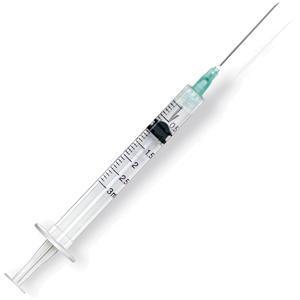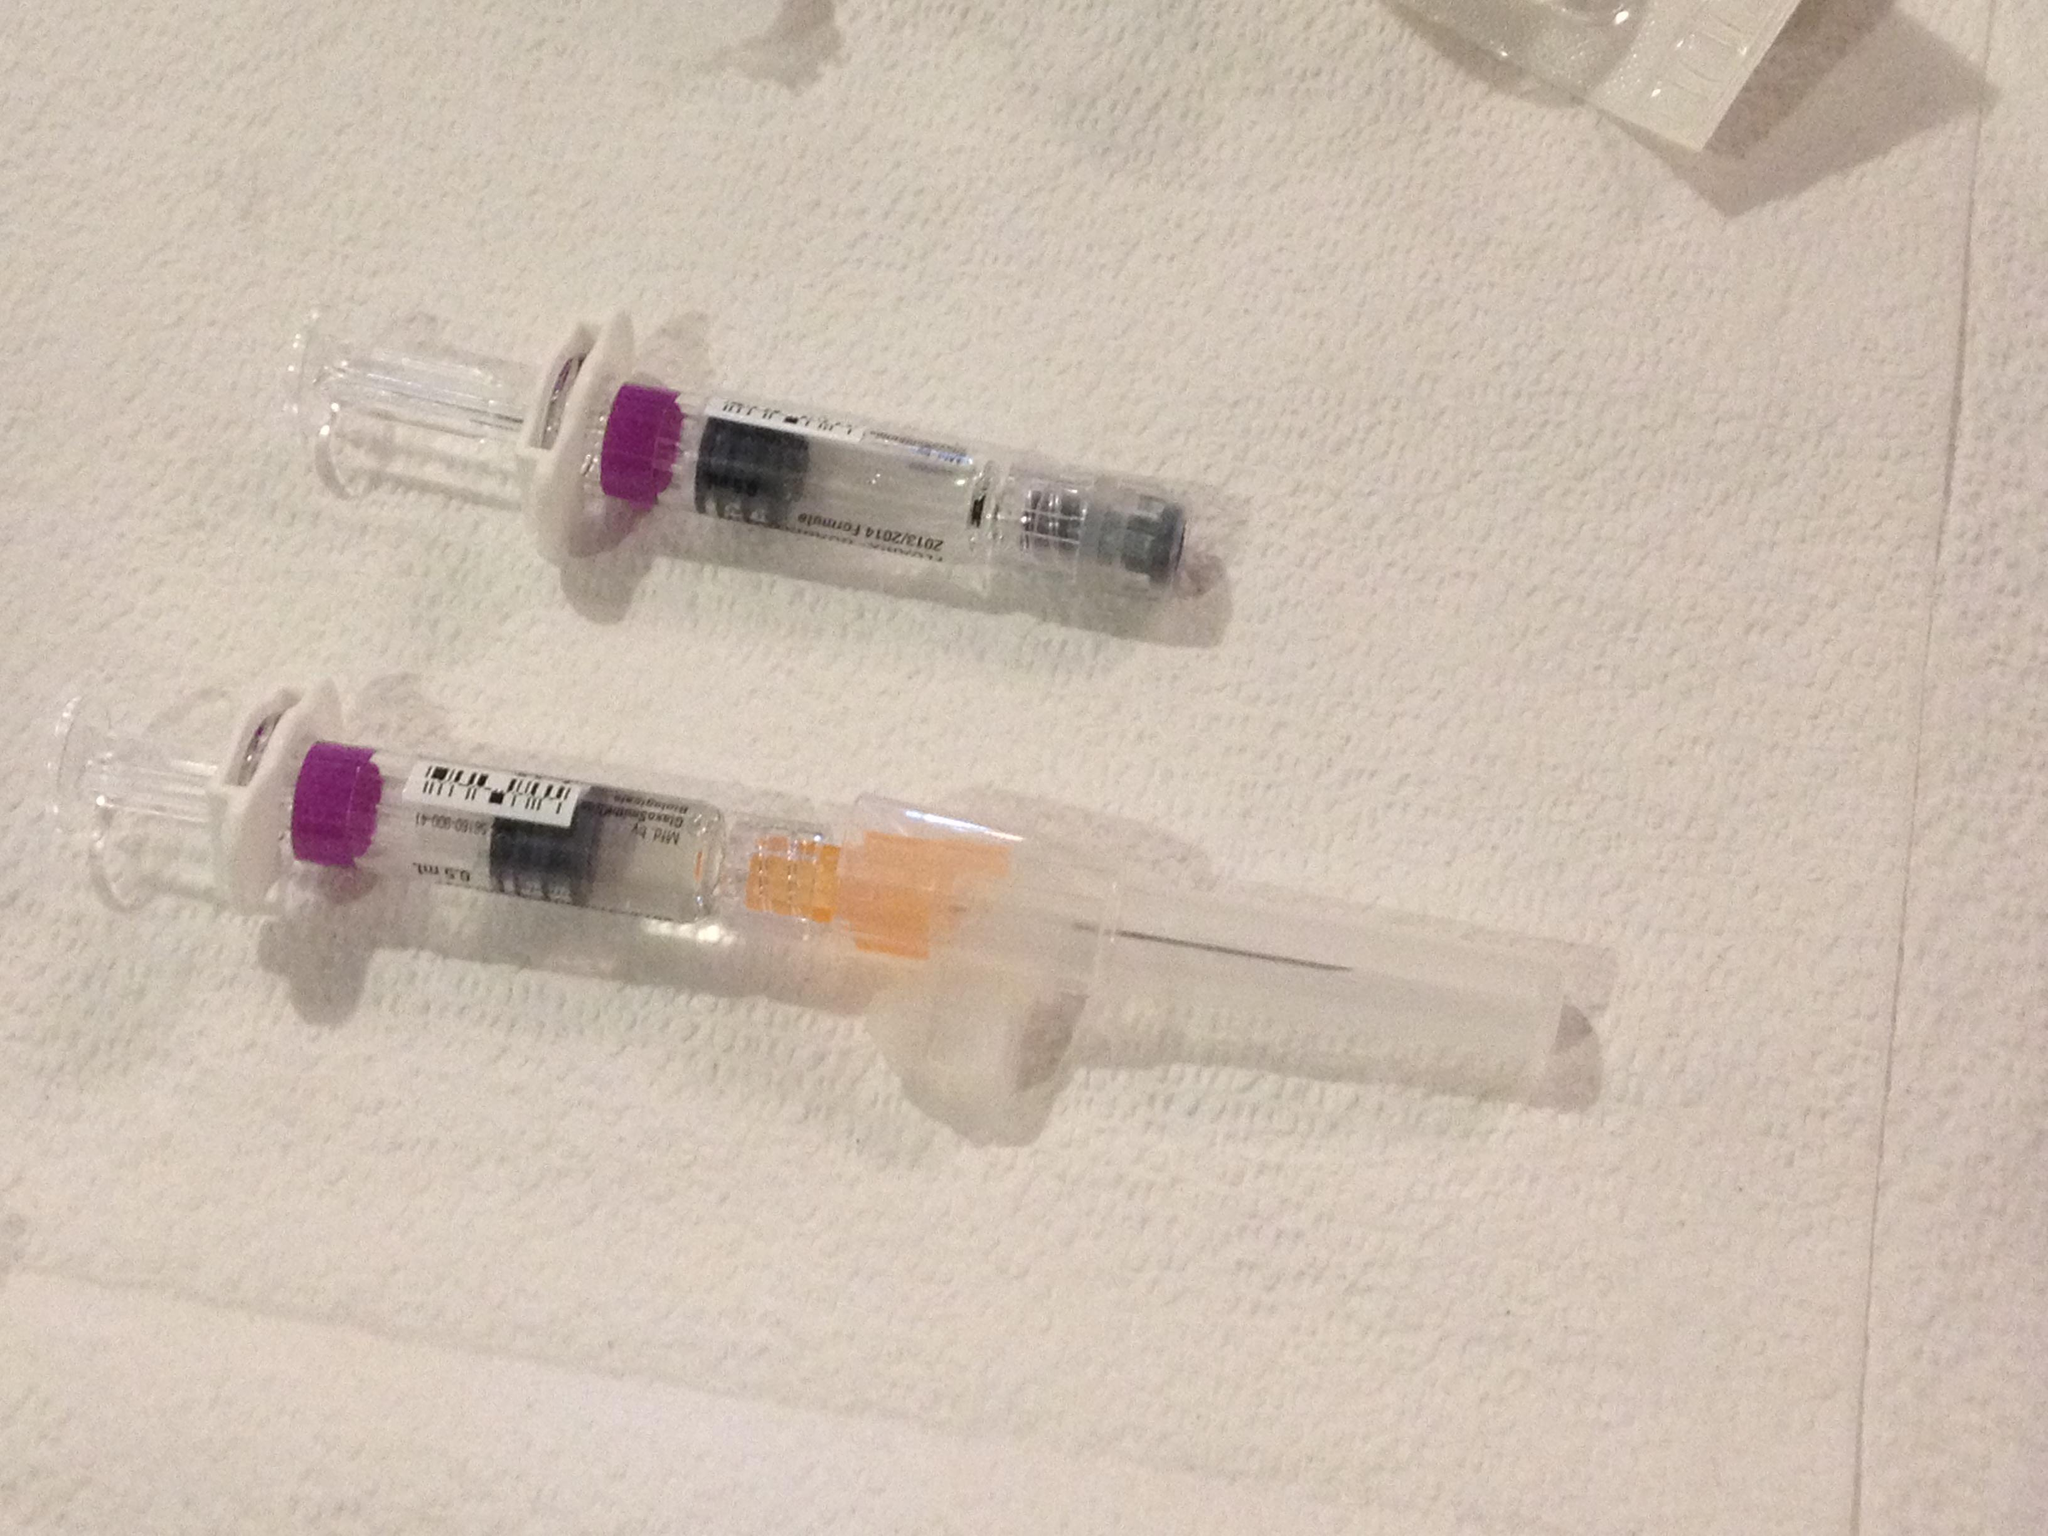The first image is the image on the left, the second image is the image on the right. Assess this claim about the two images: "The right image includes more syringe-type tubes than the left image.". Correct or not? Answer yes or no. Yes. The first image is the image on the left, the second image is the image on the right. Analyze the images presented: Is the assertion "There are more syringes in the image on the right." valid? Answer yes or no. Yes. 